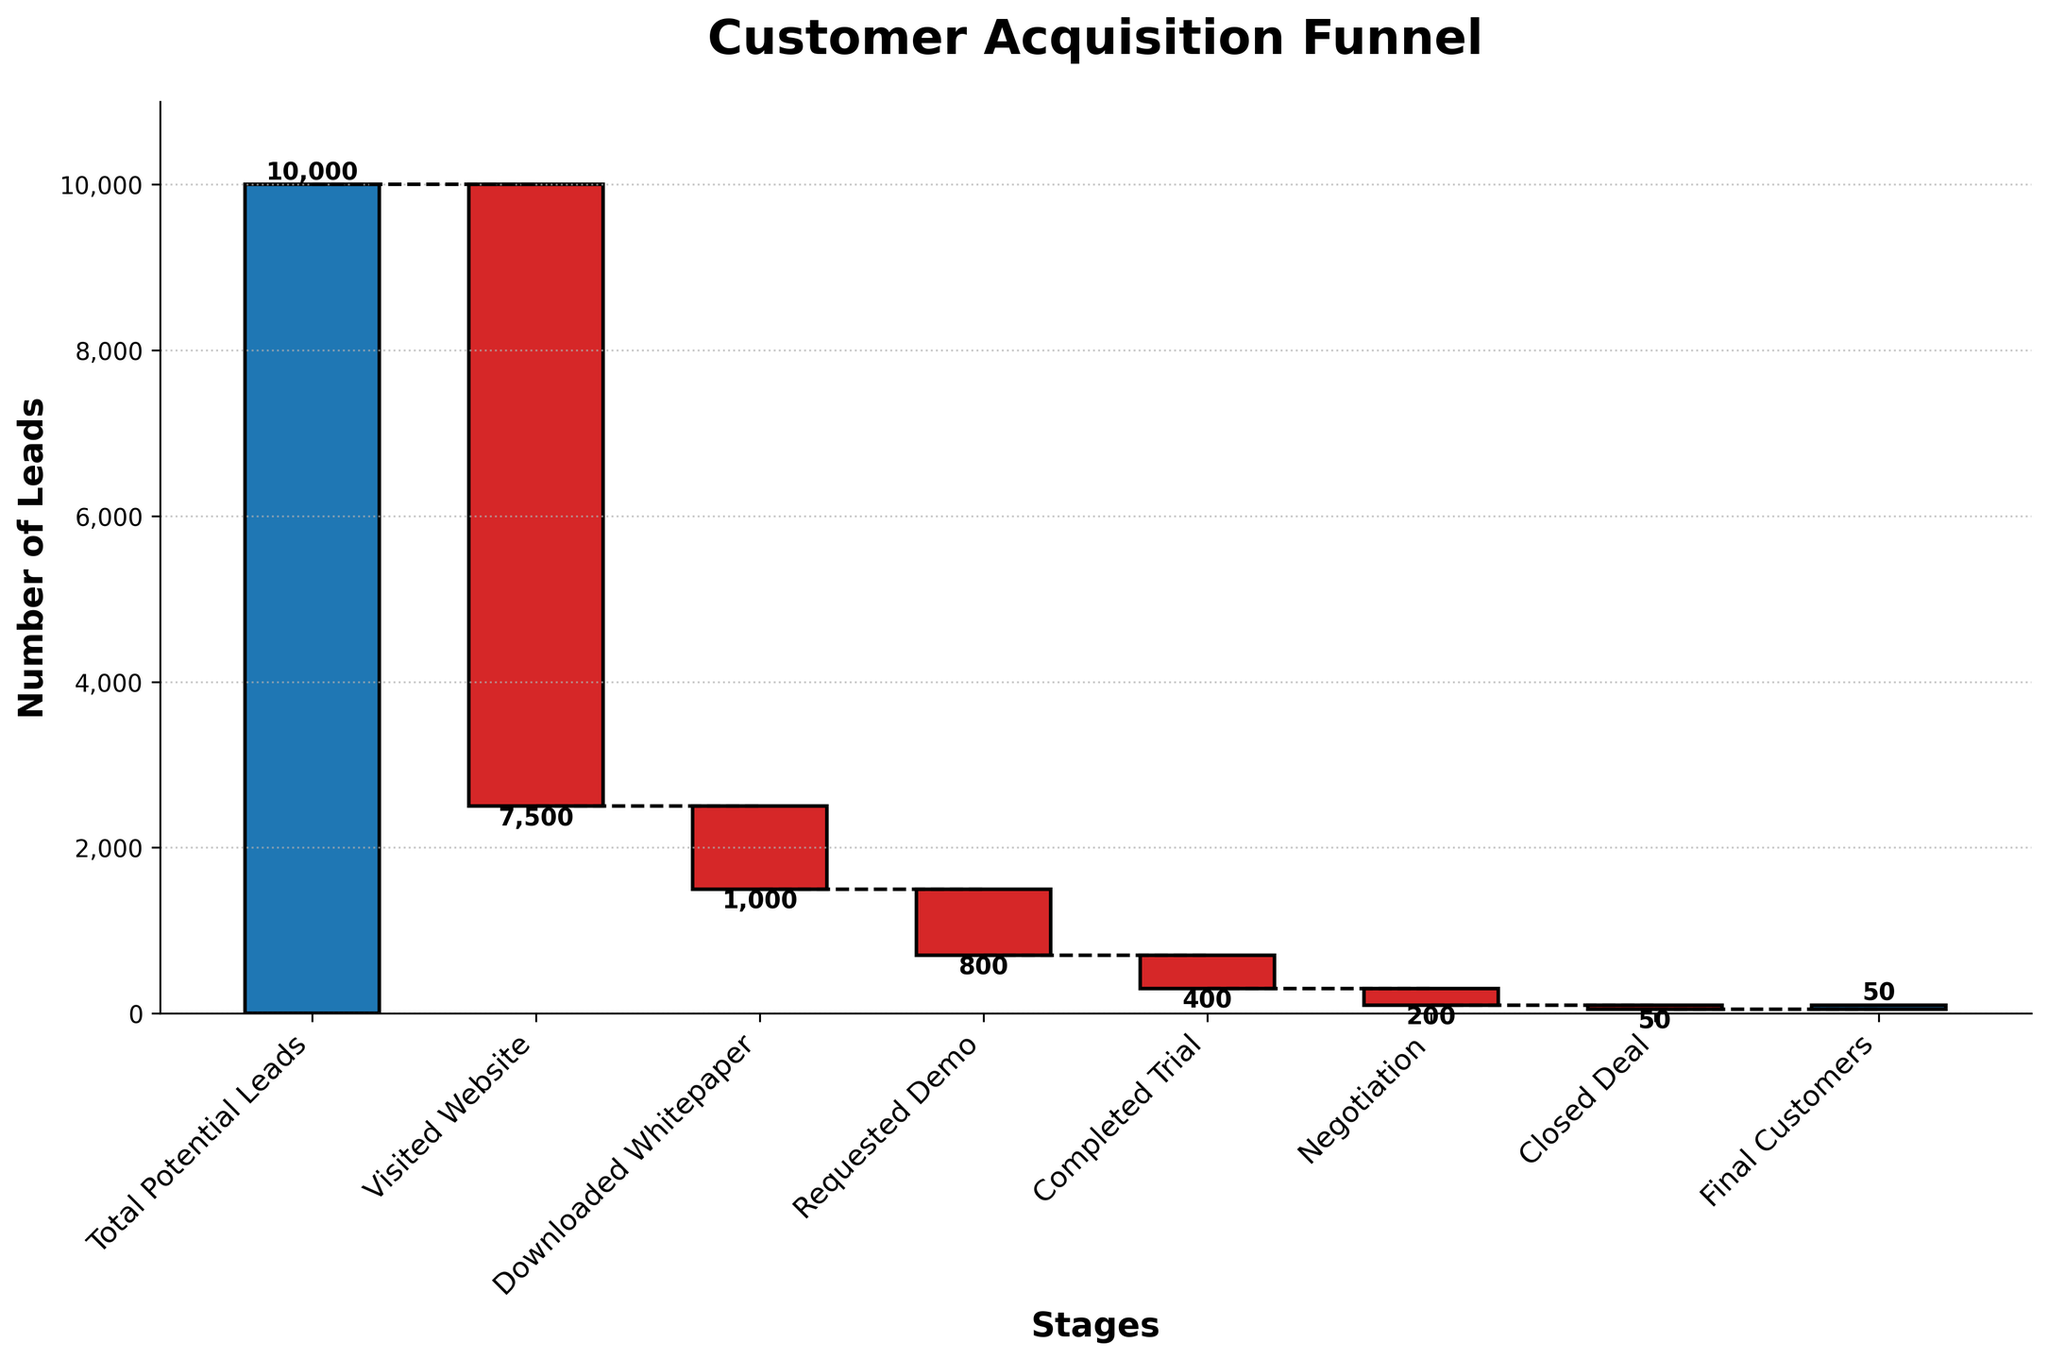What is the title of the chart? The title of the chart is centrally placed at the top of the figure and reads "Customer Acquisition Funnel."
Answer: Customer Acquisition Funnel Which stage has the highest number of potential leads? The first bar on the left represents the "Total Potential Leads" stage, which has the highest value of leads, namely 10,000.
Answer: Total Potential Leads How many leads visited the website? The second bar, labeled "Visited Website," shows a value of -7,500, indicating the number of leads who visited the website.
Answer: 7,500 What is the final number of customers acquired? The last bar in the waterfall chart represents the "Final Customers" stage, with a value of 50 indicated on the bar.
Answer: 50 What is the cumulative number of leads after the "Visited Website" stage? The first stage starts with 10,000 leads, and after deducting the 7,500 from the "Visited Website" stage, the cumulative number is 10,000 - 7,500 = 2,500.
Answer: 2,500 How does the number of leads change from "Requested Demo" to "Closed Deal"? From "Requested Demo" (-800) to "Completed Trial" (-400) to "Negotiation" (-200) to "Closed Deal" (-50), the changes are -800 - 400 - 200 - 50. This process reduces the number of leads by 1,450 leads in total from "Requested Demo" to "Closed Deal".
Answer: Reduces by 1,450 Which stage has the largest drop in leads? The stage with the largest negative value is "Visited Website," which shows a reduction of 7,500 leads, the largest drop among all stages.
Answer: Visited Website How many leads requested a demo? The bar labeled "Requested Demo" shows a value of -800, indicating that 800 leads requested a demo.
Answer: 800 Compare the number of leads who downloaded the whitepaper with those who completed the trial. The "Downloaded Whitepaper" stage has a value of -1,000, and the "Completed Trial" stage has a value of -400. So, the number of leads who downloaded the whitepaper is more than those who completed the trial, specifically 1,000 vs. 400.
Answer: Whitepaper more by 600 What fraction of the total potential leads turned into final customers? The total potential leads are 10,000, and the final customers are 50. So, the fraction is 50/10,000 = 0.005, which converts to 0.5% of the total potential leads.
Answer: 0.5% 